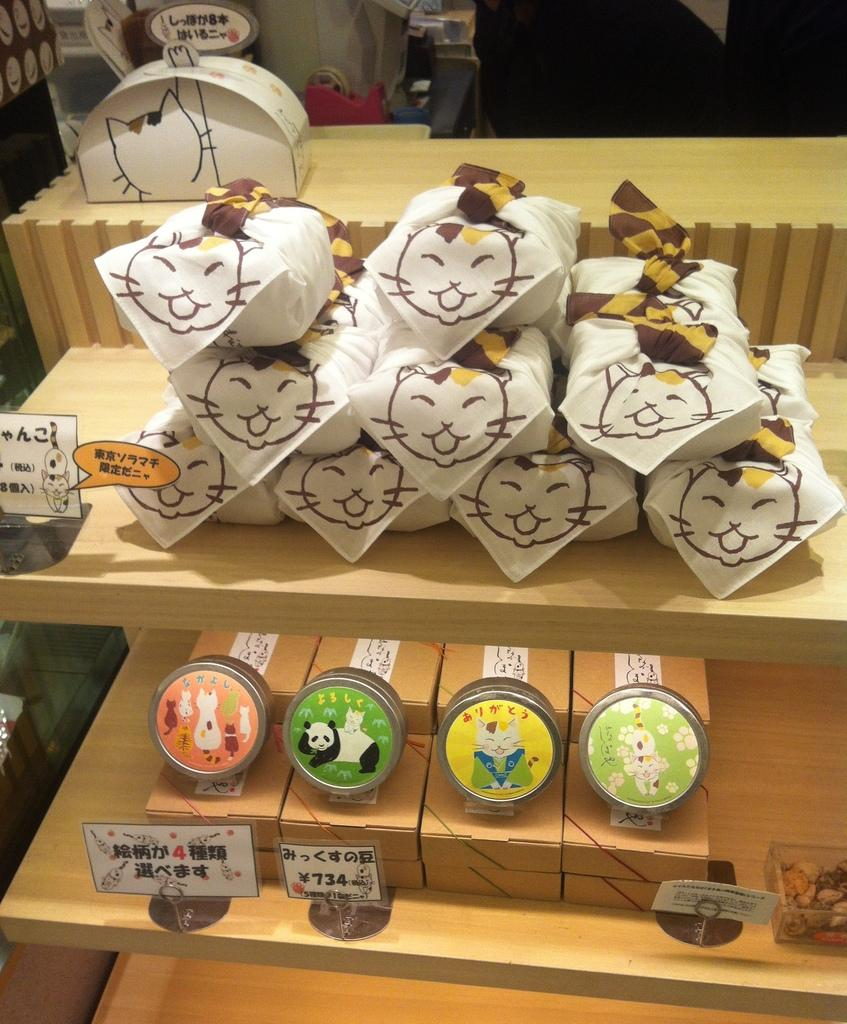What can be seen in the foreground of the image? There are wooden racks in the foreground of the image. What is located in the tracks in the image? There are boxes, packets, name boards, and food items in the tracks. Can you describe the objects at the top of the image? There is a box at the top of the image, along with various other objects. Can you see a cat holding an umbrella with its finger in the image? There is no cat, umbrella, or finger present in the image. 